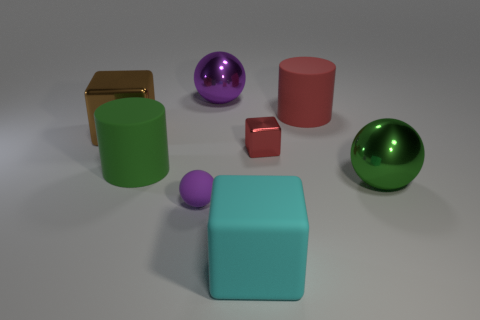What size is the brown object that is the same shape as the cyan matte thing?
Keep it short and to the point. Large. There is a cylinder that is to the right of the cyan cube; is there a large green matte thing that is on the left side of it?
Ensure brevity in your answer.  Yes. How many other objects are the same shape as the big brown metal thing?
Offer a terse response. 2. Are there more large balls to the left of the large green metal sphere than small balls behind the big green rubber cylinder?
Ensure brevity in your answer.  Yes. Do the green object on the right side of the green rubber thing and the shiny block that is on the left side of the purple shiny ball have the same size?
Make the answer very short. Yes. The green matte thing has what shape?
Your response must be concise. Cylinder. The cylinder that is the same color as the tiny metallic cube is what size?
Ensure brevity in your answer.  Large. There is another block that is made of the same material as the red block; what color is it?
Make the answer very short. Brown. Does the tiny sphere have the same material as the big cylinder in front of the large red rubber cylinder?
Make the answer very short. Yes. The tiny matte object has what color?
Offer a very short reply. Purple. 